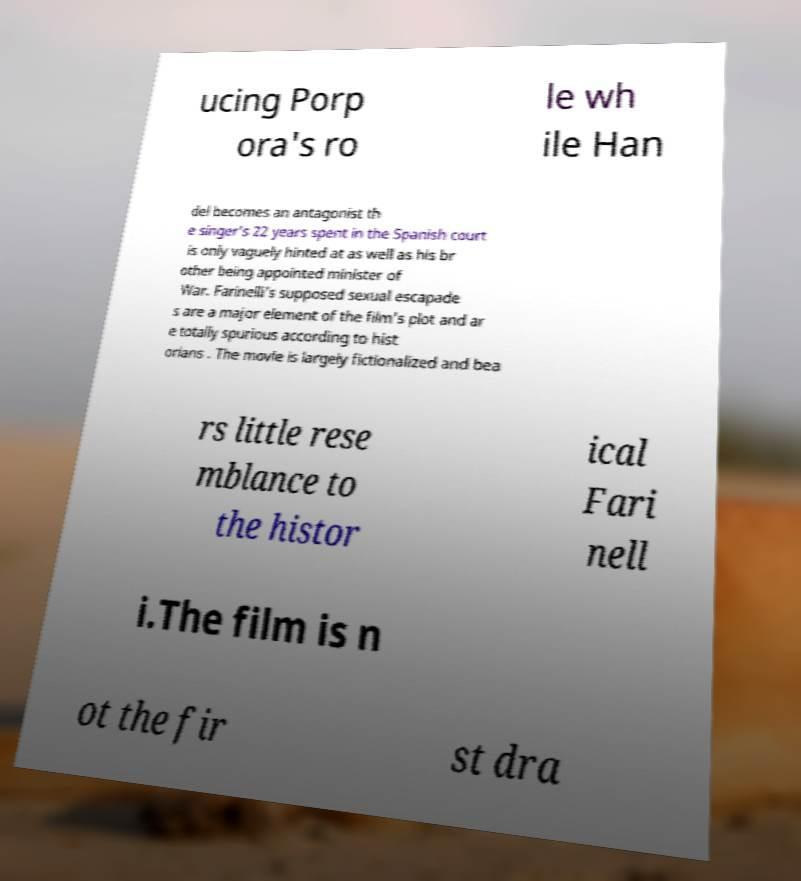Could you assist in decoding the text presented in this image and type it out clearly? ucing Porp ora's ro le wh ile Han del becomes an antagonist th e singer's 22 years spent in the Spanish court is only vaguely hinted at as well as his br other being appointed minister of War. Farinelli's supposed sexual escapade s are a major element of the film's plot and ar e totally spurious according to hist orians . The movie is largely fictionalized and bea rs little rese mblance to the histor ical Fari nell i.The film is n ot the fir st dra 